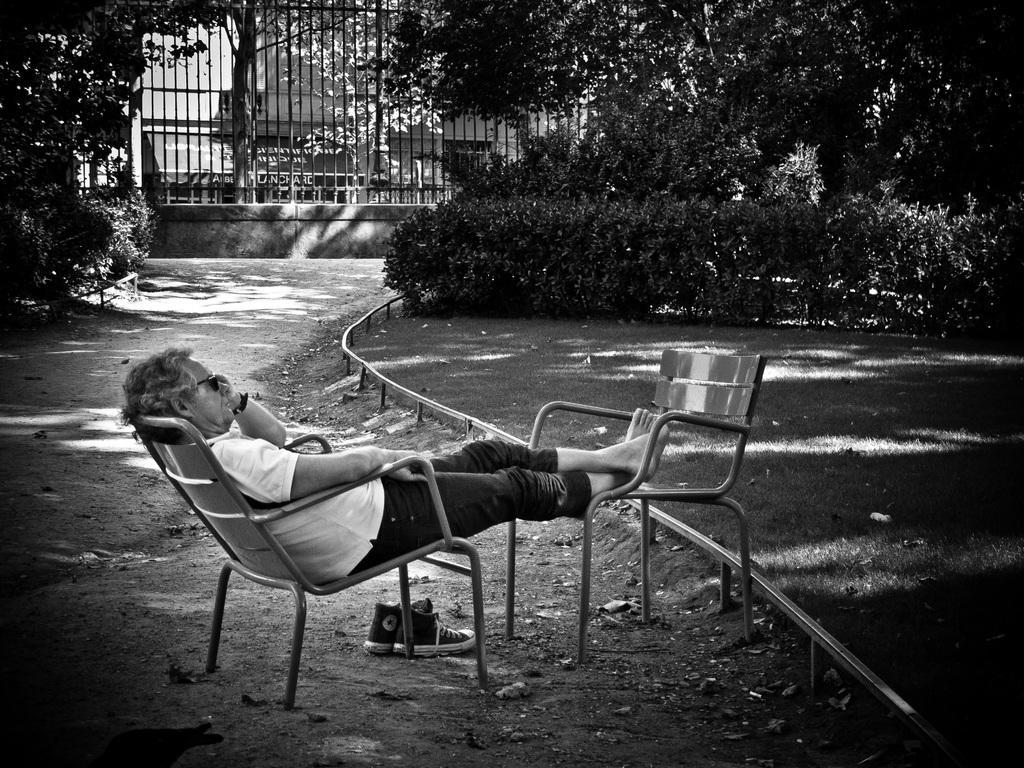Describe this image in one or two sentences. This image is taken outdoors. At the bottom of the image there is a ground. In the background there is railing and there is a building. There are many trees and plants with leaves, stems and branches. In the middle of the image a man is sitting on the chair and he is placing his legs on the other chair. There are two shoes on the ground. 